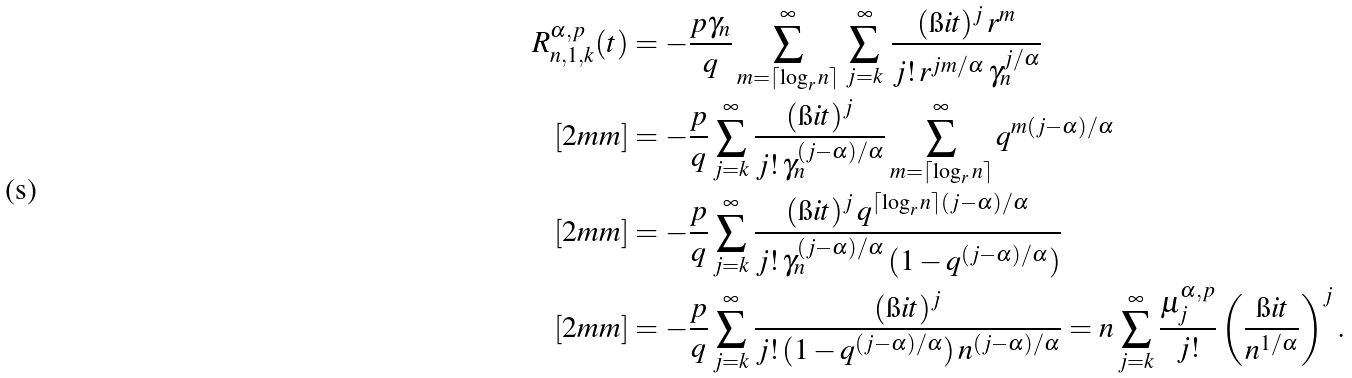<formula> <loc_0><loc_0><loc_500><loc_500>R _ { n , 1 , k } ^ { \alpha , p } ( t ) & = - \frac { p \gamma _ { n } } { q } \sum _ { m = \lceil \log _ { r } n \rceil } ^ { \infty } \, \sum _ { j = k } ^ { \infty } \, \frac { ( \i i t ) ^ { j } \, r ^ { m } } { j ! \, r ^ { j m / \alpha } \, \gamma _ { n } ^ { j / \alpha } } \\ [ 2 m m ] & = - \frac { p } { q } \sum _ { j = k } ^ { \infty } \frac { ( \i i t ) ^ { j } } { j ! \, \gamma _ { n } ^ { ( j - \alpha ) / \alpha } } \sum _ { m = \lceil \log _ { r } n \rceil } ^ { \infty } q ^ { m ( j - \alpha ) / \alpha } \\ [ 2 m m ] & = - \frac { p } { q } \sum _ { j = k } ^ { \infty } \frac { ( \i i t ) ^ { j } \, q ^ { \lceil \log _ { r } n \rceil ( j - \alpha ) / \alpha } } { j ! \, \gamma _ { n } ^ { ( j - \alpha ) / \alpha } \, ( 1 - q ^ { ( j - \alpha ) / \alpha } ) } \\ [ 2 m m ] & = - \frac { p } { q } \sum _ { j = k } ^ { \infty } \frac { ( \i i t ) ^ { j } } { j ! \, ( 1 - q ^ { ( j - \alpha ) / \alpha } ) \, n ^ { ( j - \alpha ) / \alpha } } = n \sum _ { j = k } ^ { \infty } \frac { \mu _ { j } ^ { \alpha , p } } { j ! } \left ( \frac { \i i t } { n ^ { 1 / \alpha } } \right ) ^ { j } .</formula> 